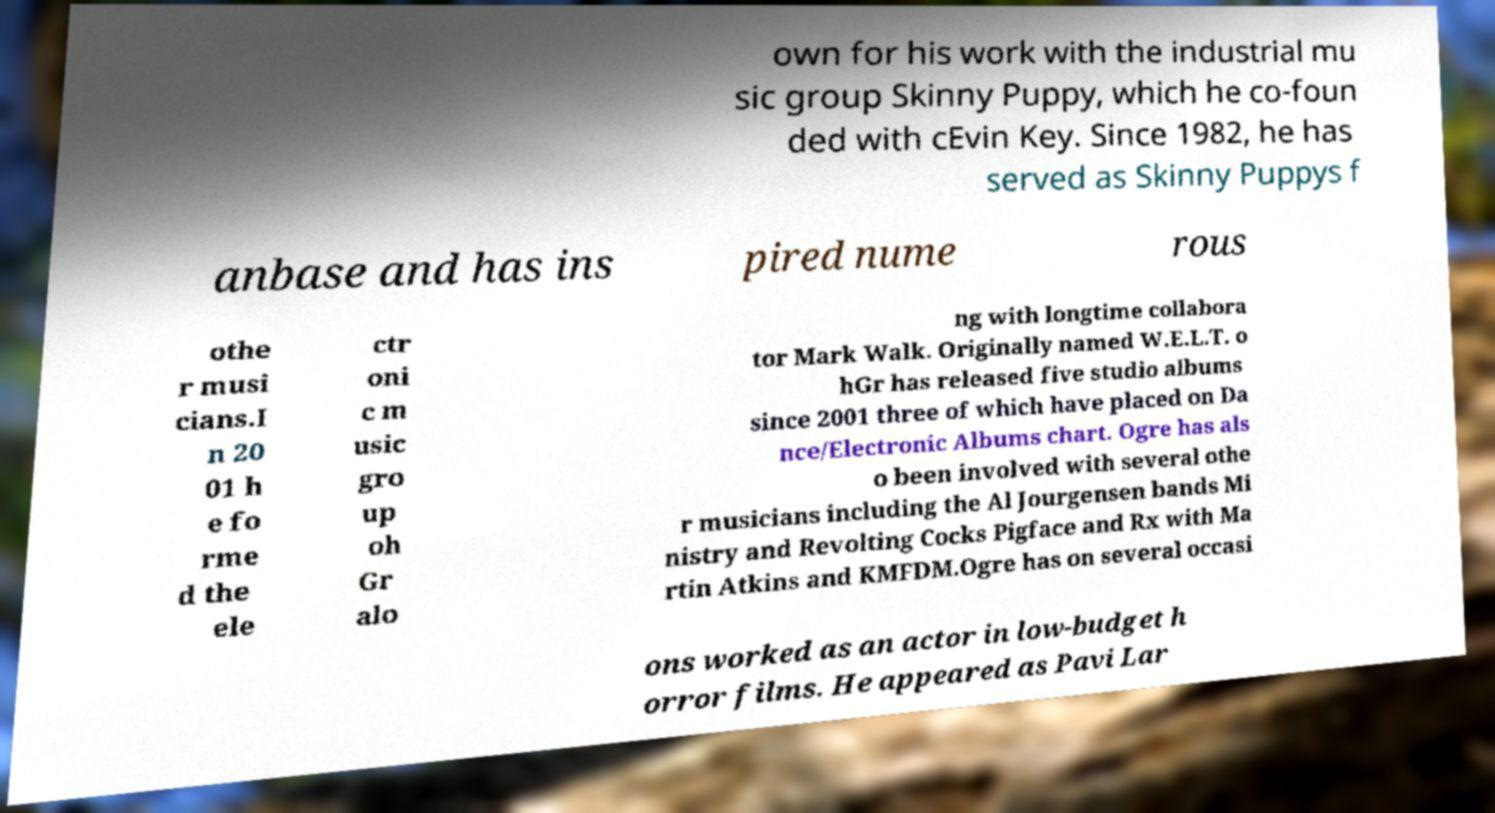Please read and relay the text visible in this image. What does it say? own for his work with the industrial mu sic group Skinny Puppy, which he co-foun ded with cEvin Key. Since 1982, he has served as Skinny Puppys f anbase and has ins pired nume rous othe r musi cians.I n 20 01 h e fo rme d the ele ctr oni c m usic gro up oh Gr alo ng with longtime collabora tor Mark Walk. Originally named W.E.L.T. o hGr has released five studio albums since 2001 three of which have placed on Da nce/Electronic Albums chart. Ogre has als o been involved with several othe r musicians including the Al Jourgensen bands Mi nistry and Revolting Cocks Pigface and Rx with Ma rtin Atkins and KMFDM.Ogre has on several occasi ons worked as an actor in low-budget h orror films. He appeared as Pavi Lar 